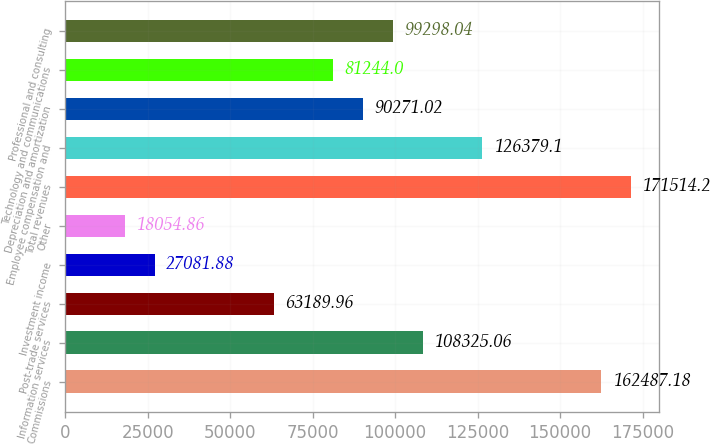Convert chart to OTSL. <chart><loc_0><loc_0><loc_500><loc_500><bar_chart><fcel>Commissions<fcel>Information services<fcel>Post-trade services<fcel>Investment income<fcel>Other<fcel>Total revenues<fcel>Employee compensation and<fcel>Depreciation and amortization<fcel>Technology and communications<fcel>Professional and consulting<nl><fcel>162487<fcel>108325<fcel>63190<fcel>27081.9<fcel>18054.9<fcel>171514<fcel>126379<fcel>90271<fcel>81244<fcel>99298<nl></chart> 